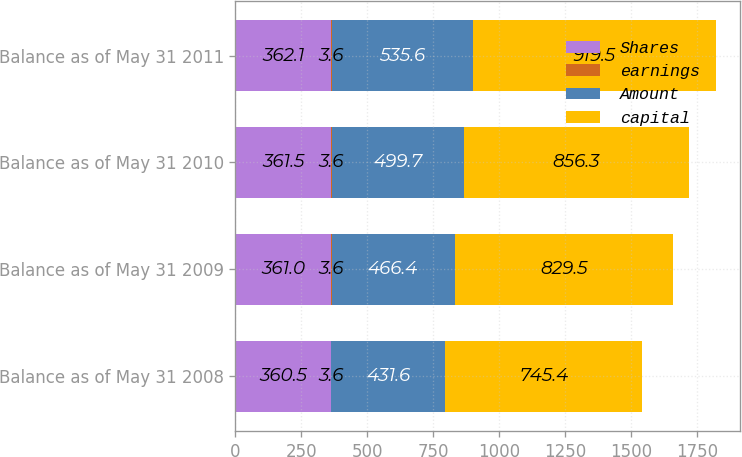Convert chart. <chart><loc_0><loc_0><loc_500><loc_500><stacked_bar_chart><ecel><fcel>Balance as of May 31 2008<fcel>Balance as of May 31 2009<fcel>Balance as of May 31 2010<fcel>Balance as of May 31 2011<nl><fcel>Shares<fcel>360.5<fcel>361<fcel>361.5<fcel>362.1<nl><fcel>earnings<fcel>3.6<fcel>3.6<fcel>3.6<fcel>3.6<nl><fcel>Amount<fcel>431.6<fcel>466.4<fcel>499.7<fcel>535.6<nl><fcel>capital<fcel>745.4<fcel>829.5<fcel>856.3<fcel>919.5<nl></chart> 